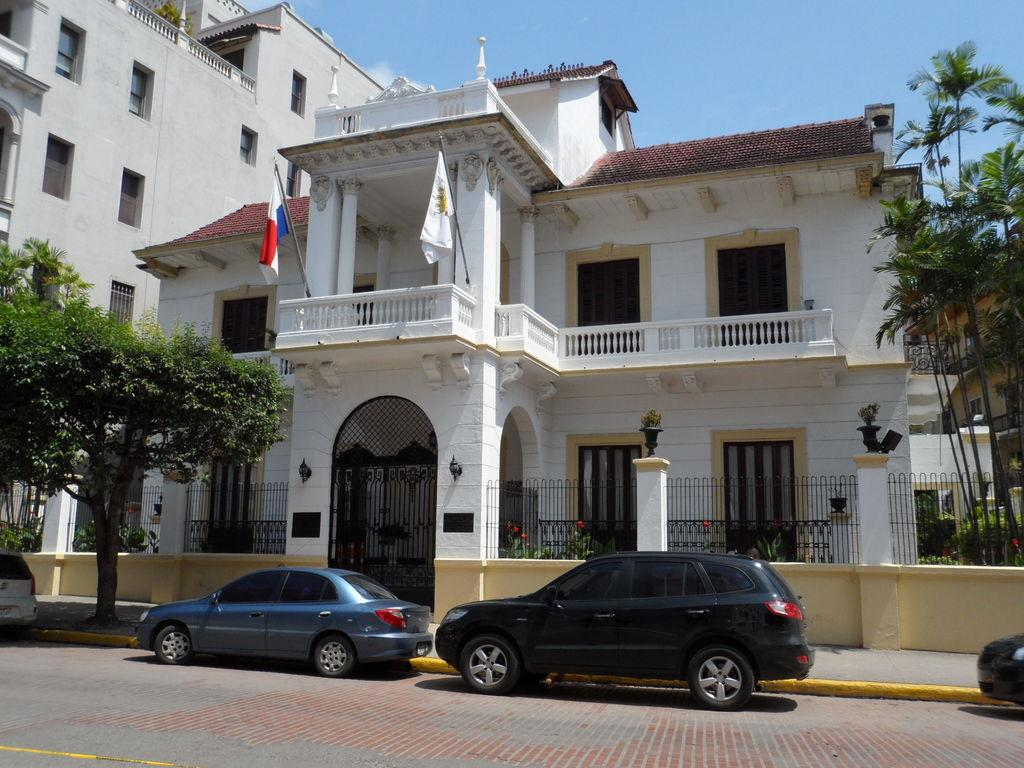What type of vehicles can be seen on the road in the image? There are cars on the road in the image. What is located beside the cars on the road? There are trees beside the cars. What type of barrier is present in the image? There is a fence in the image. What type of structures can be seen in the image? There are buildings in the image. What additional decorative elements are present in the image? There are flags in the image. What type of wool is being used to create the pan in the image? There is no pan or wool present in the image. 